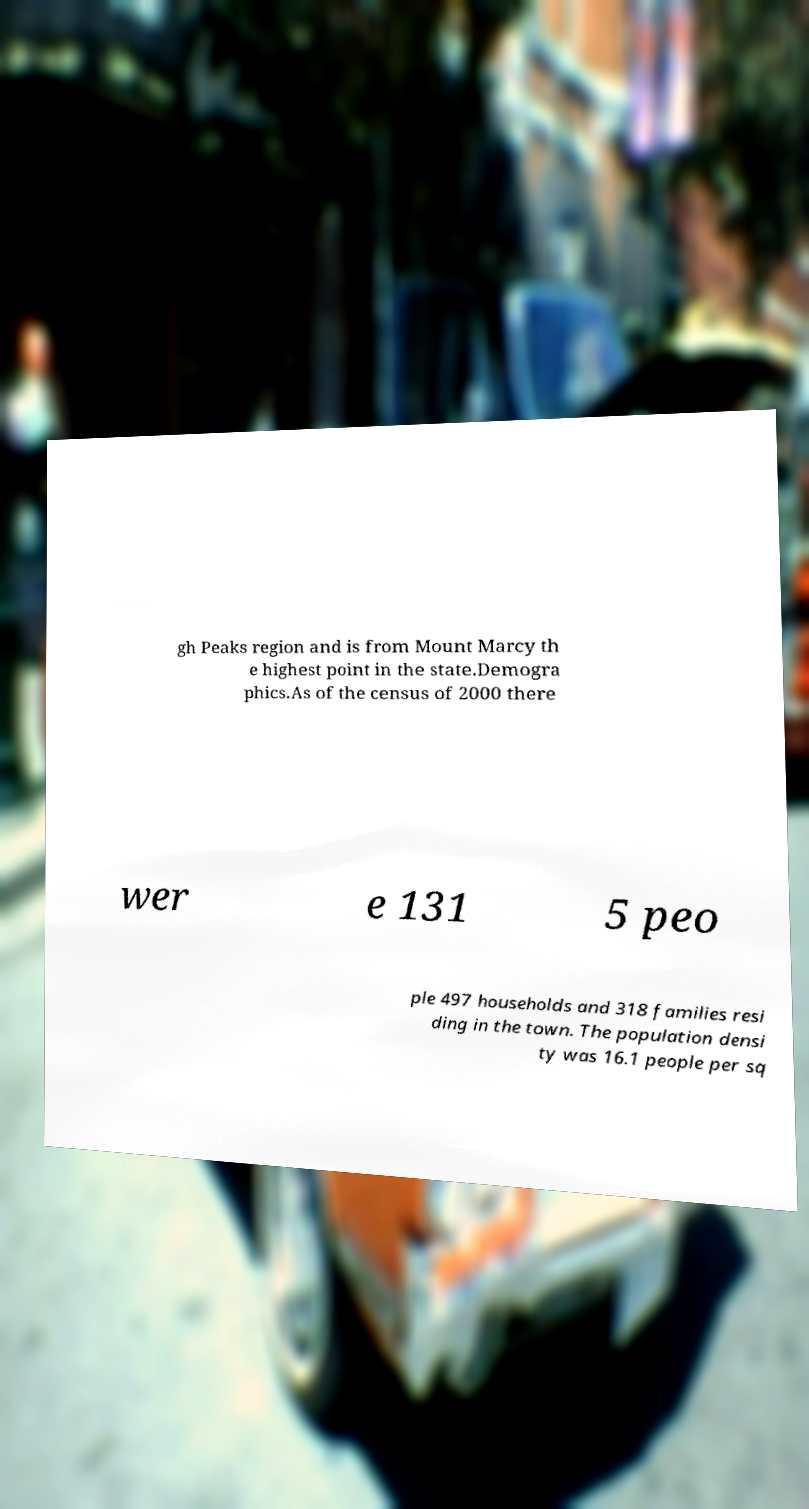Please identify and transcribe the text found in this image. gh Peaks region and is from Mount Marcy th e highest point in the state.Demogra phics.As of the census of 2000 there wer e 131 5 peo ple 497 households and 318 families resi ding in the town. The population densi ty was 16.1 people per sq 